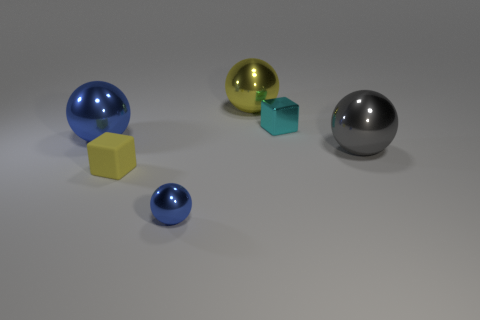There is a yellow thing right of the yellow rubber thing in front of the block on the right side of the small yellow block; what size is it?
Your answer should be compact. Large. What is the size of the gray object that is the same shape as the large yellow thing?
Provide a succinct answer. Large. How many large objects are brown cylinders or gray shiny objects?
Offer a terse response. 1. Do the blue object that is in front of the large gray object and the cube to the right of the yellow cube have the same material?
Provide a succinct answer. Yes. What is the yellow thing that is in front of the big blue metal thing made of?
Give a very brief answer. Rubber. What number of metallic objects are big objects or tiny green balls?
Offer a terse response. 3. There is a big metallic sphere that is on the left side of the tiny metal thing on the left side of the small cyan metallic object; what is its color?
Keep it short and to the point. Blue. Does the large gray ball have the same material as the ball that is in front of the gray object?
Provide a succinct answer. Yes. There is a metal ball behind the large metallic ball that is to the left of the blue object in front of the big blue object; what is its color?
Your response must be concise. Yellow. Are there any other things that are the same shape as the large blue object?
Provide a succinct answer. Yes. 